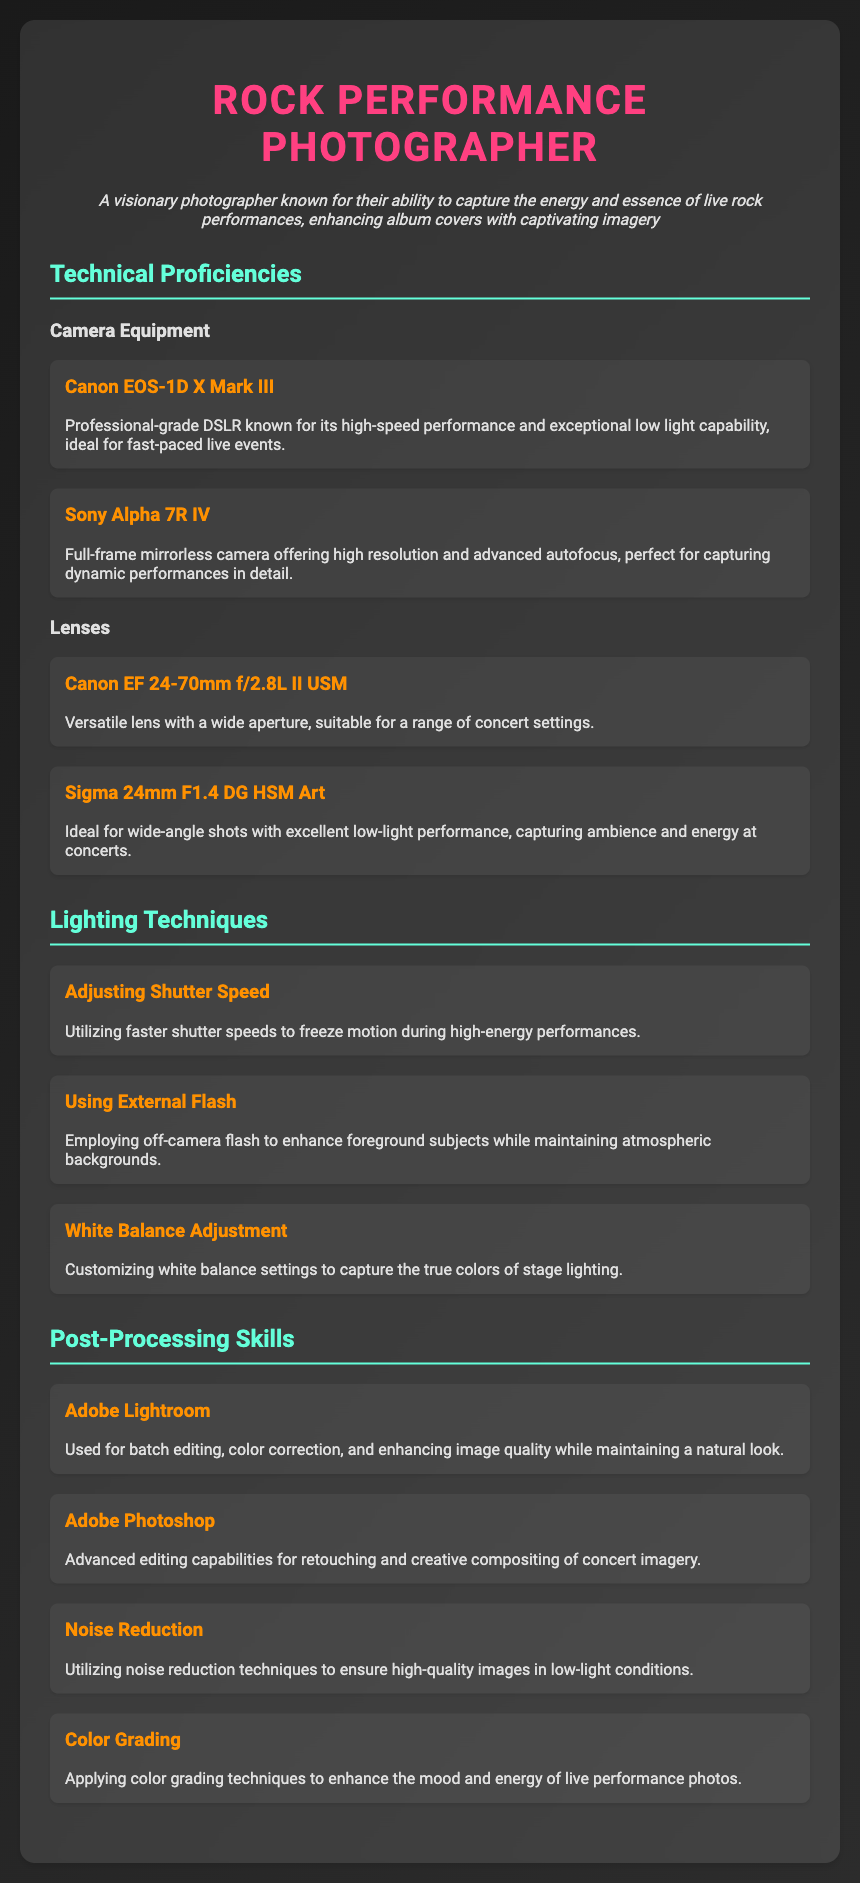What camera model is known for its high-speed performance? The Canon EOS-1D X Mark III is mentioned as a professional-grade DSLR known for its high-speed performance and exceptional low light capability.
Answer: Canon EOS-1D X Mark III Which lens is described as ideal for wide-angle shots? The Sigma 24mm F1.4 DG HSM Art is specifically noted for being ideal for wide-angle shots with excellent low-light performance.
Answer: Sigma 24mm F1.4 DG HSM Art How many lighting techniques are listed in the document? There are three lighting techniques mentioned in the document: Adjusting Shutter Speed, Using External Flash, and White Balance Adjustment.
Answer: Three What is the primary software used for batch editing? Adobe Lightroom is identified as the software used for batch editing, color correction, and enhancing image quality.
Answer: Adobe Lightroom What technique is used to enhance foreground subjects? The document states that using off-camera flash is a technique employed to enhance foreground subjects while maintaining atmospheric backgrounds.
Answer: Off-camera flash Which post-processing skill involves noise reduction? The document mentions noise reduction as a post-processing skill utilized to ensure high-quality images in low-light conditions.
Answer: Noise Reduction What type of photographer is described in the introduction? The introduction identifies the individual as a visionary photographer known for capturing the energy and essence of live rock performances.
Answer: Visionary photographer What keyword is associated with color grading in the document? Color grading techniques are applied to enhance the mood and energy of live performance photos, as mentioned specifically in the post-processing section.
Answer: Color grading techniques 